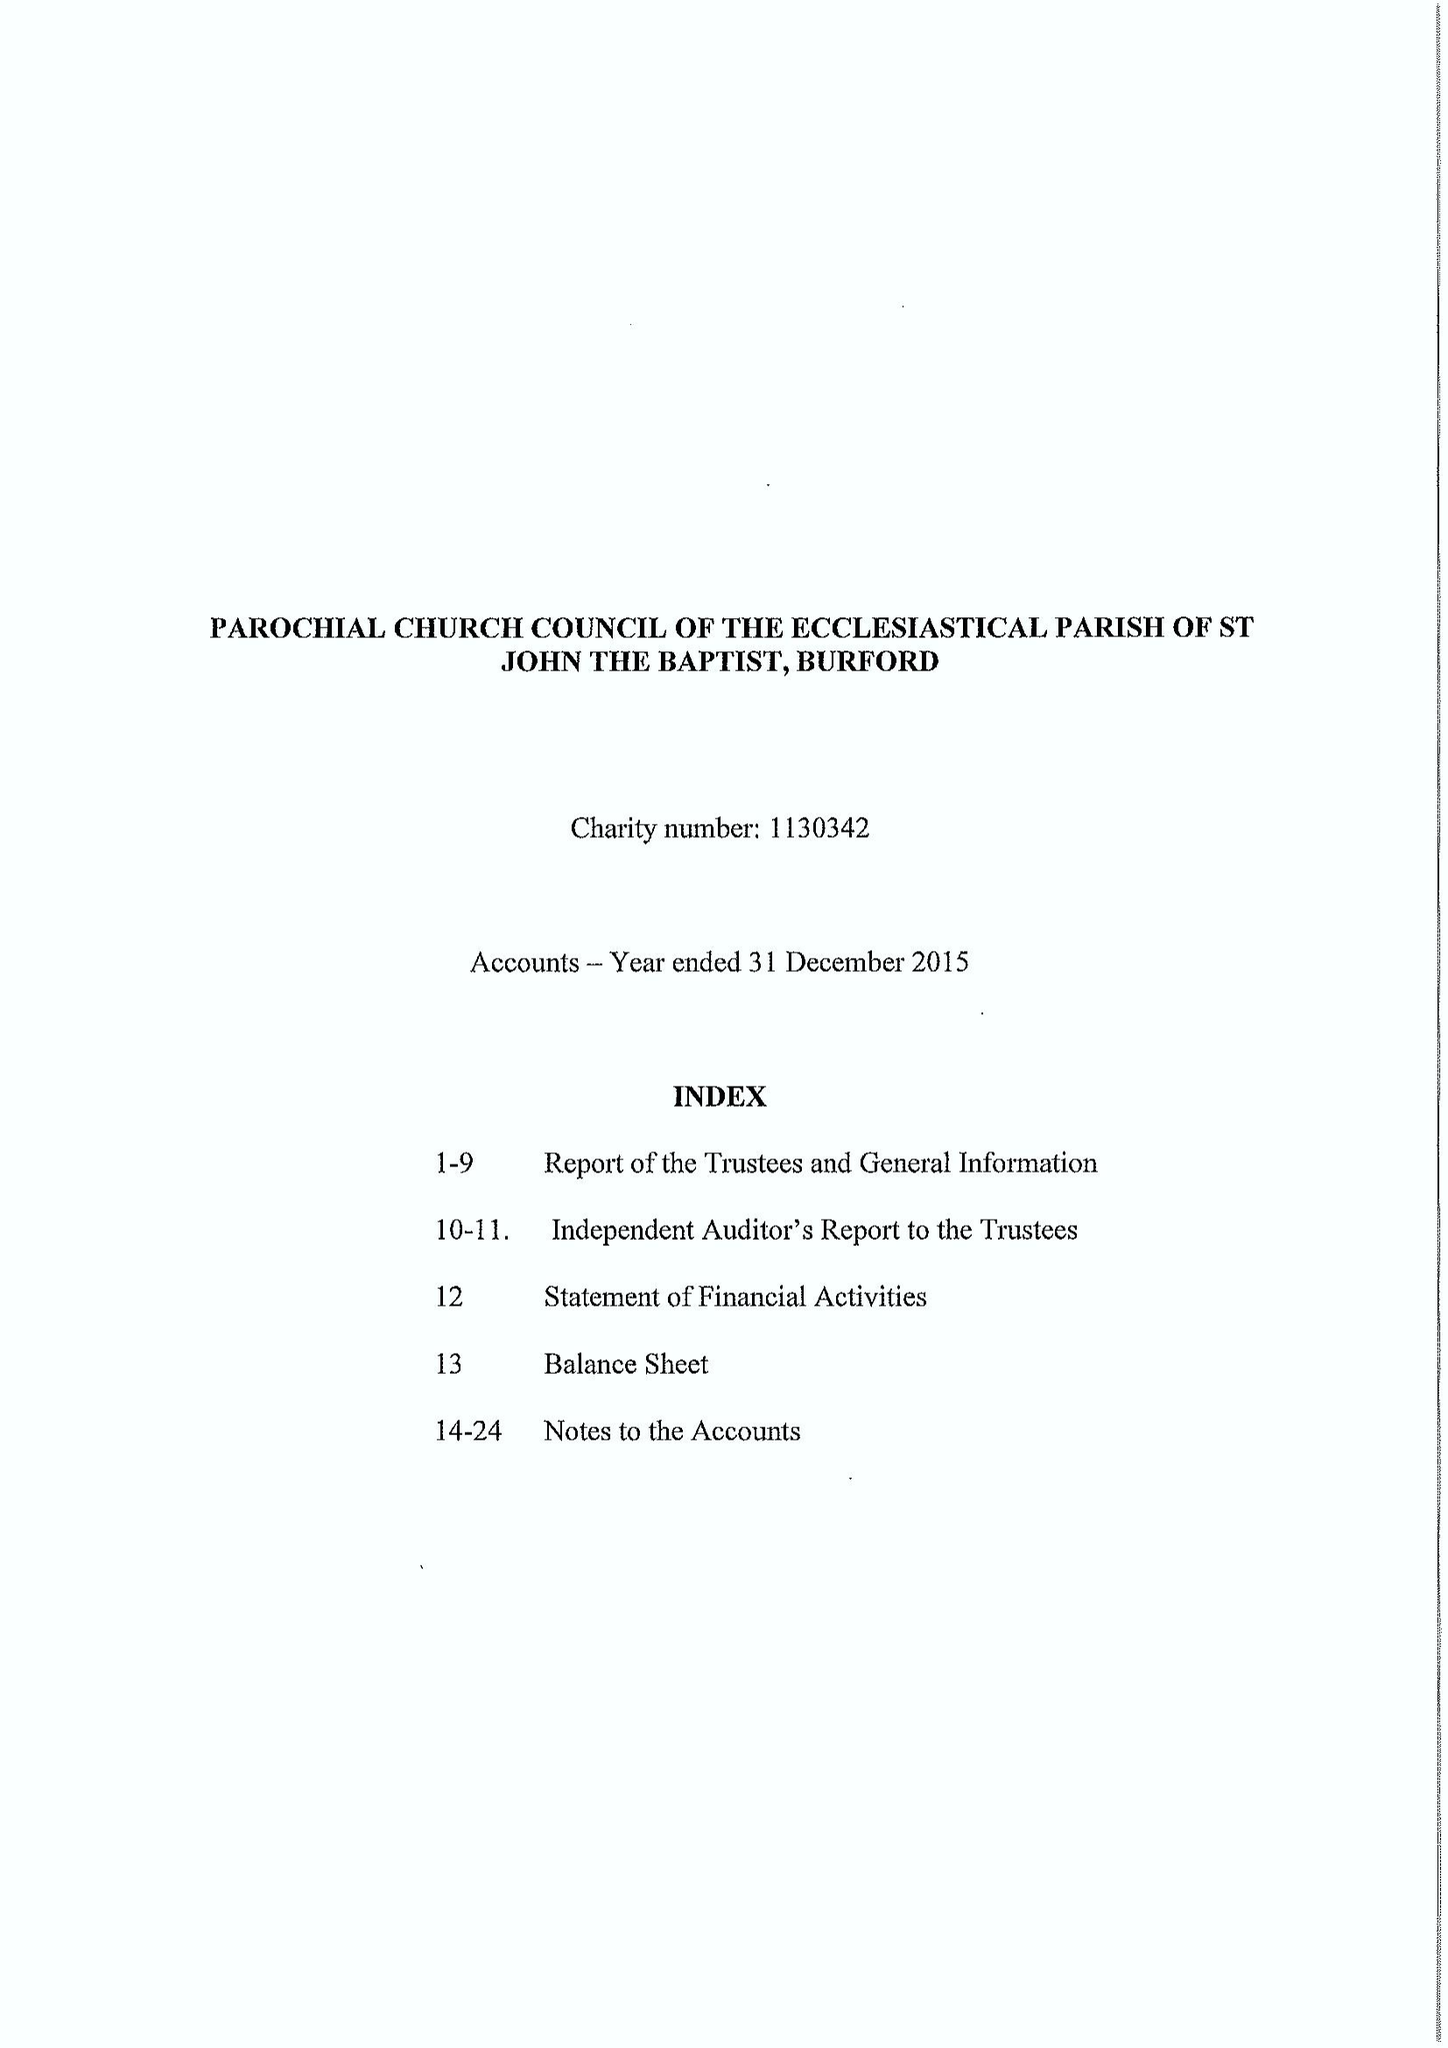What is the value for the spending_annually_in_british_pounds?
Answer the question using a single word or phrase. 312503.00 